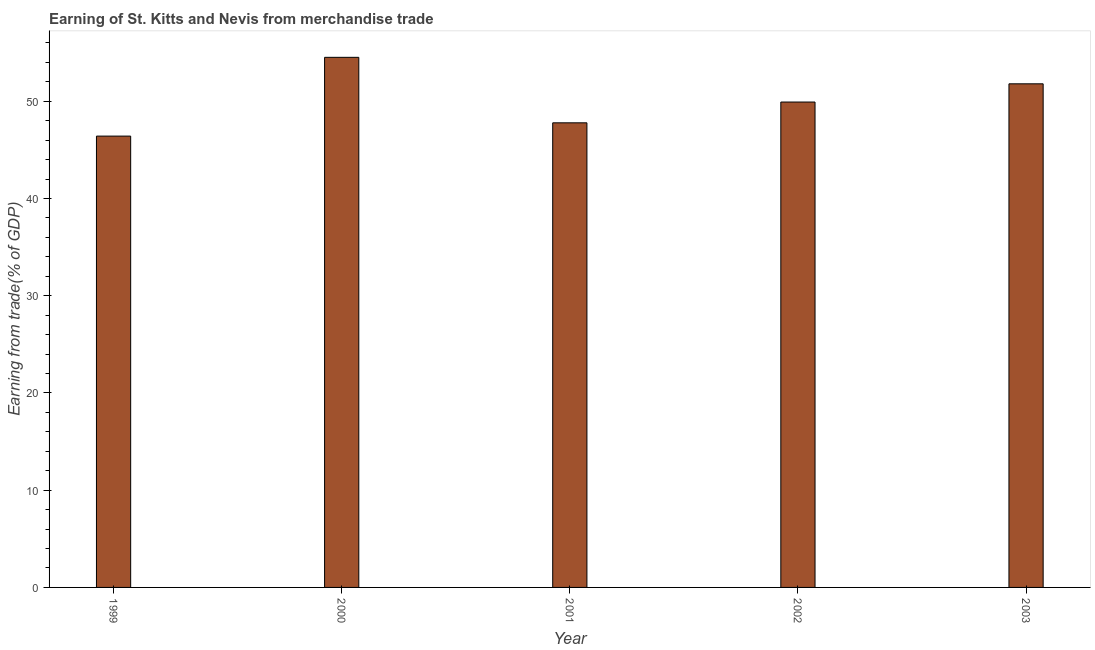Does the graph contain grids?
Make the answer very short. No. What is the title of the graph?
Offer a terse response. Earning of St. Kitts and Nevis from merchandise trade. What is the label or title of the X-axis?
Make the answer very short. Year. What is the label or title of the Y-axis?
Your response must be concise. Earning from trade(% of GDP). What is the earning from merchandise trade in 2002?
Provide a short and direct response. 49.91. Across all years, what is the maximum earning from merchandise trade?
Your response must be concise. 54.51. Across all years, what is the minimum earning from merchandise trade?
Your response must be concise. 46.41. In which year was the earning from merchandise trade maximum?
Keep it short and to the point. 2000. In which year was the earning from merchandise trade minimum?
Your answer should be compact. 1999. What is the sum of the earning from merchandise trade?
Make the answer very short. 250.41. What is the difference between the earning from merchandise trade in 1999 and 2000?
Your answer should be compact. -8.1. What is the average earning from merchandise trade per year?
Provide a short and direct response. 50.08. What is the median earning from merchandise trade?
Your response must be concise. 49.91. What is the ratio of the earning from merchandise trade in 2001 to that in 2003?
Your response must be concise. 0.92. Is the earning from merchandise trade in 2000 less than that in 2002?
Provide a short and direct response. No. Is the difference between the earning from merchandise trade in 2002 and 2003 greater than the difference between any two years?
Keep it short and to the point. No. What is the difference between the highest and the second highest earning from merchandise trade?
Provide a short and direct response. 2.72. How many bars are there?
Provide a succinct answer. 5. Are all the bars in the graph horizontal?
Ensure brevity in your answer.  No. How many years are there in the graph?
Ensure brevity in your answer.  5. Are the values on the major ticks of Y-axis written in scientific E-notation?
Your answer should be very brief. No. What is the Earning from trade(% of GDP) of 1999?
Your answer should be very brief. 46.41. What is the Earning from trade(% of GDP) of 2000?
Offer a very short reply. 54.51. What is the Earning from trade(% of GDP) of 2001?
Offer a very short reply. 47.78. What is the Earning from trade(% of GDP) of 2002?
Your answer should be very brief. 49.91. What is the Earning from trade(% of GDP) of 2003?
Provide a succinct answer. 51.79. What is the difference between the Earning from trade(% of GDP) in 1999 and 2000?
Your answer should be compact. -8.1. What is the difference between the Earning from trade(% of GDP) in 1999 and 2001?
Your answer should be compact. -1.37. What is the difference between the Earning from trade(% of GDP) in 1999 and 2002?
Provide a succinct answer. -3.5. What is the difference between the Earning from trade(% of GDP) in 1999 and 2003?
Provide a succinct answer. -5.38. What is the difference between the Earning from trade(% of GDP) in 2000 and 2001?
Offer a very short reply. 6.74. What is the difference between the Earning from trade(% of GDP) in 2000 and 2002?
Keep it short and to the point. 4.6. What is the difference between the Earning from trade(% of GDP) in 2000 and 2003?
Give a very brief answer. 2.72. What is the difference between the Earning from trade(% of GDP) in 2001 and 2002?
Your response must be concise. -2.14. What is the difference between the Earning from trade(% of GDP) in 2001 and 2003?
Make the answer very short. -4.01. What is the difference between the Earning from trade(% of GDP) in 2002 and 2003?
Keep it short and to the point. -1.87. What is the ratio of the Earning from trade(% of GDP) in 1999 to that in 2000?
Your answer should be compact. 0.85. What is the ratio of the Earning from trade(% of GDP) in 1999 to that in 2002?
Your answer should be very brief. 0.93. What is the ratio of the Earning from trade(% of GDP) in 1999 to that in 2003?
Offer a very short reply. 0.9. What is the ratio of the Earning from trade(% of GDP) in 2000 to that in 2001?
Your answer should be very brief. 1.14. What is the ratio of the Earning from trade(% of GDP) in 2000 to that in 2002?
Keep it short and to the point. 1.09. What is the ratio of the Earning from trade(% of GDP) in 2000 to that in 2003?
Make the answer very short. 1.05. What is the ratio of the Earning from trade(% of GDP) in 2001 to that in 2002?
Your answer should be compact. 0.96. What is the ratio of the Earning from trade(% of GDP) in 2001 to that in 2003?
Your answer should be compact. 0.92. 